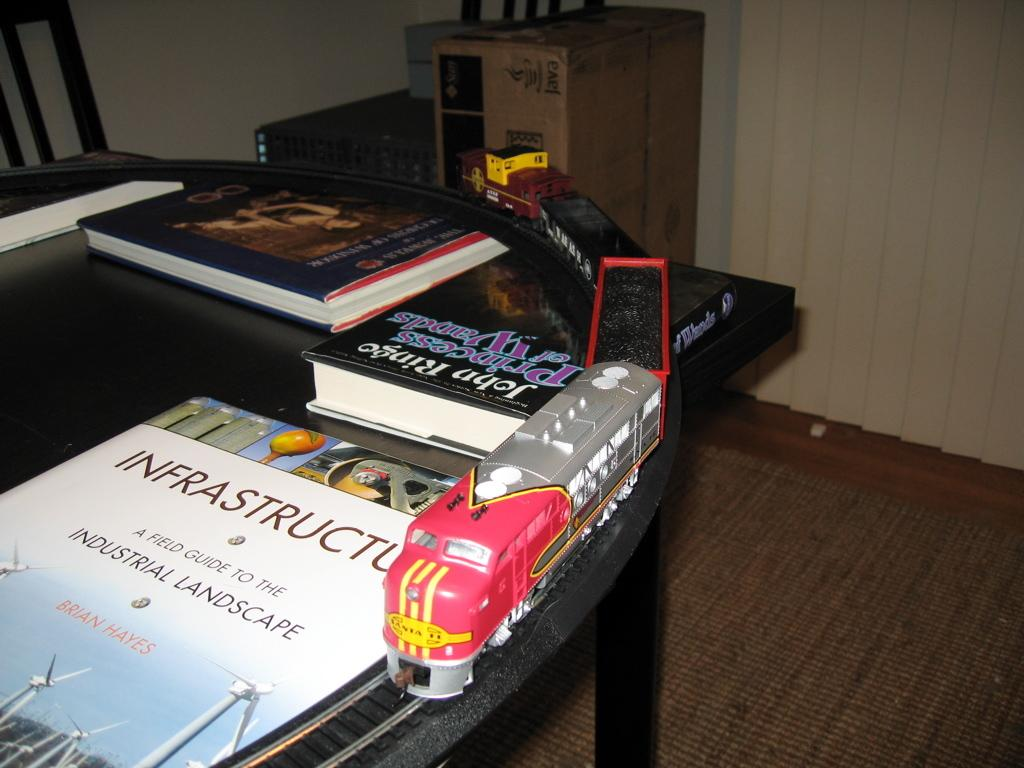<image>
Relay a brief, clear account of the picture shown. A train set on a table next to a book called Infrastructure A Field Guide to the Industrial Landscape 